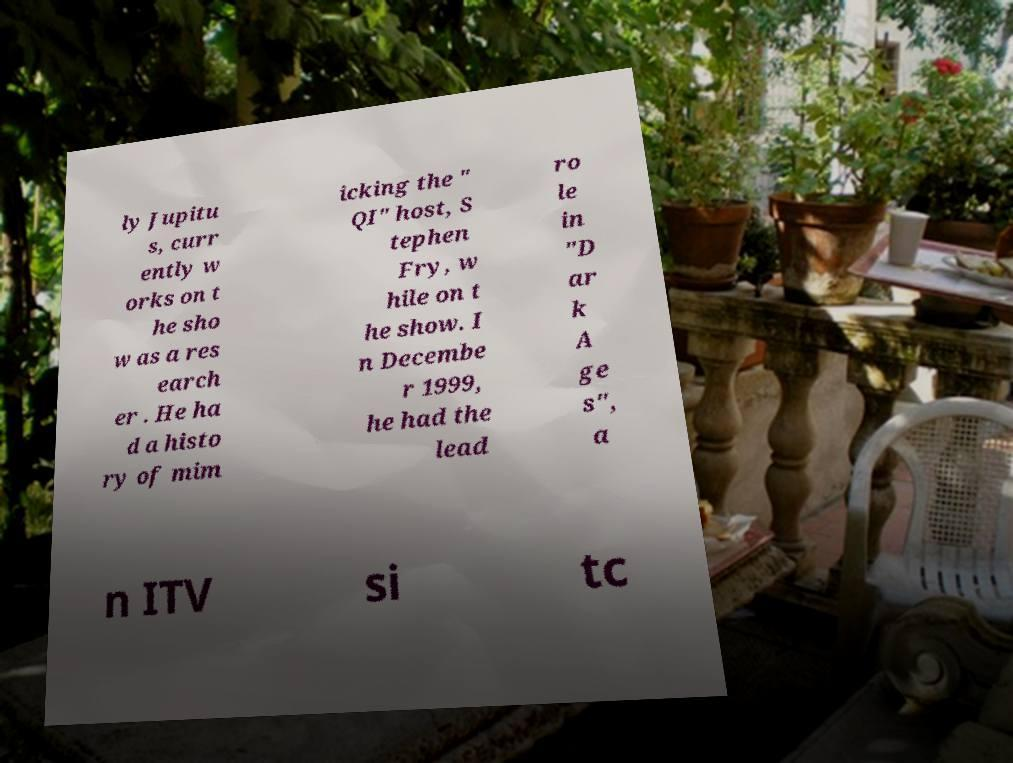Please read and relay the text visible in this image. What does it say? ly Jupitu s, curr ently w orks on t he sho w as a res earch er . He ha d a histo ry of mim icking the " QI" host, S tephen Fry, w hile on t he show. I n Decembe r 1999, he had the lead ro le in "D ar k A ge s", a n ITV si tc 